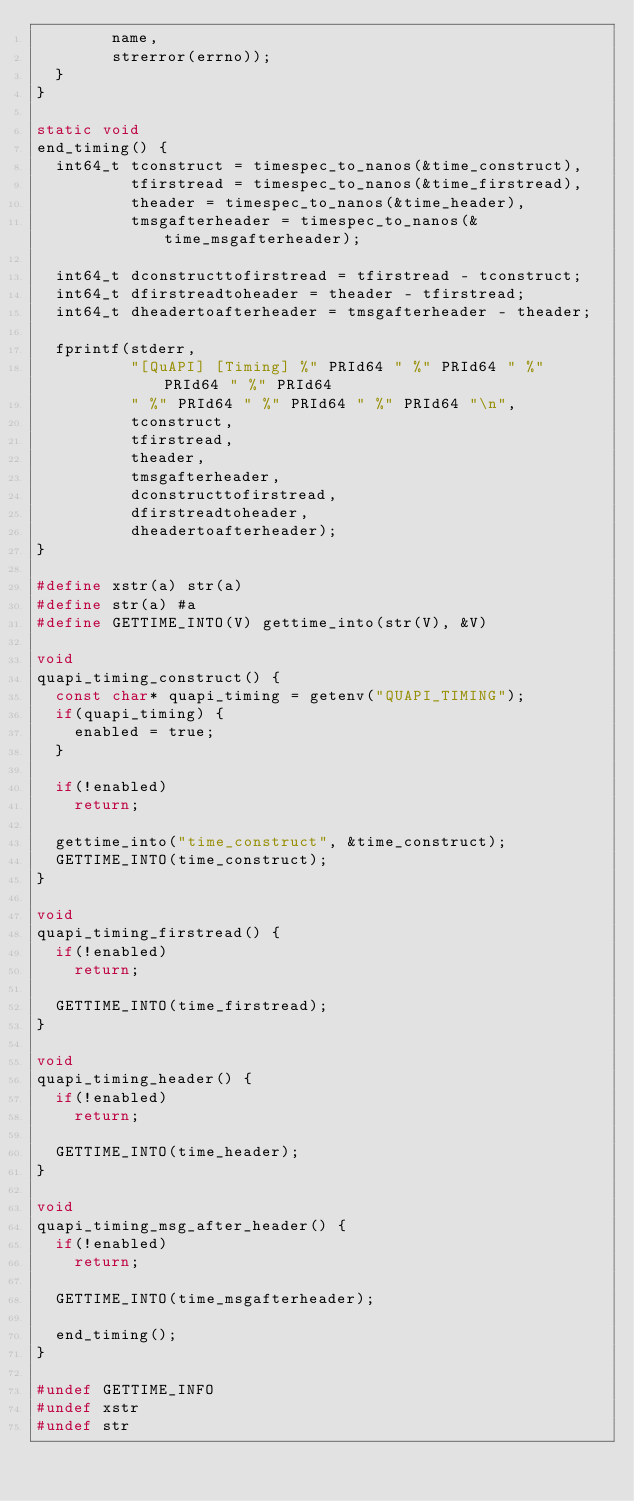Convert code to text. <code><loc_0><loc_0><loc_500><loc_500><_C_>        name,
        strerror(errno));
  }
}

static void
end_timing() {
  int64_t tconstruct = timespec_to_nanos(&time_construct),
          tfirstread = timespec_to_nanos(&time_firstread),
          theader = timespec_to_nanos(&time_header),
          tmsgafterheader = timespec_to_nanos(&time_msgafterheader);

  int64_t dconstructtofirstread = tfirstread - tconstruct;
  int64_t dfirstreadtoheader = theader - tfirstread;
  int64_t dheadertoafterheader = tmsgafterheader - theader;

  fprintf(stderr,
          "[QuAPI] [Timing] %" PRId64 " %" PRId64 " %" PRId64 " %" PRId64
          " %" PRId64 " %" PRId64 " %" PRId64 "\n",
          tconstruct,
          tfirstread,
          theader,
          tmsgafterheader,
          dconstructtofirstread,
          dfirstreadtoheader,
          dheadertoafterheader);
}

#define xstr(a) str(a)
#define str(a) #a
#define GETTIME_INTO(V) gettime_into(str(V), &V)

void
quapi_timing_construct() {
  const char* quapi_timing = getenv("QUAPI_TIMING");
  if(quapi_timing) {
    enabled = true;
  }

  if(!enabled)
    return;

  gettime_into("time_construct", &time_construct);
  GETTIME_INTO(time_construct);
}

void
quapi_timing_firstread() {
  if(!enabled)
    return;

  GETTIME_INTO(time_firstread);
}

void
quapi_timing_header() {
  if(!enabled)
    return;

  GETTIME_INTO(time_header);
}

void
quapi_timing_msg_after_header() {
  if(!enabled)
    return;

  GETTIME_INTO(time_msgafterheader);

  end_timing();
}

#undef GETTIME_INFO
#undef xstr
#undef str
</code> 